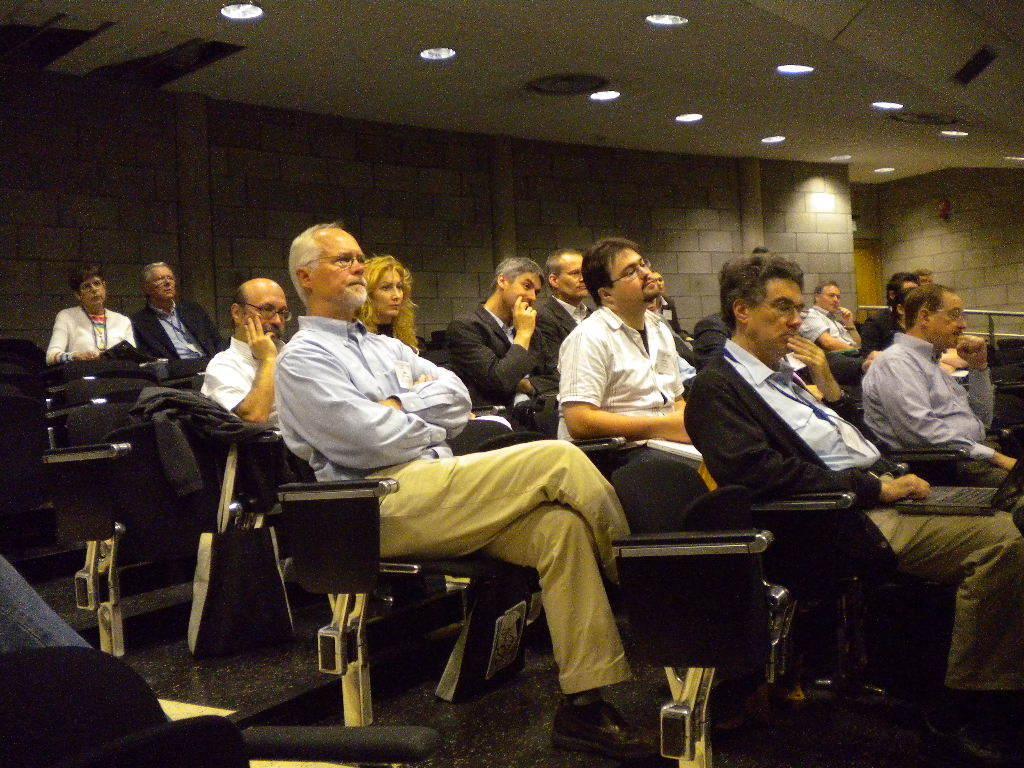Can you describe this image briefly? In this image we can see a group of people are sitting on the chairs and few people are holding some objects in their hands. There are many lights attached to the roof. 